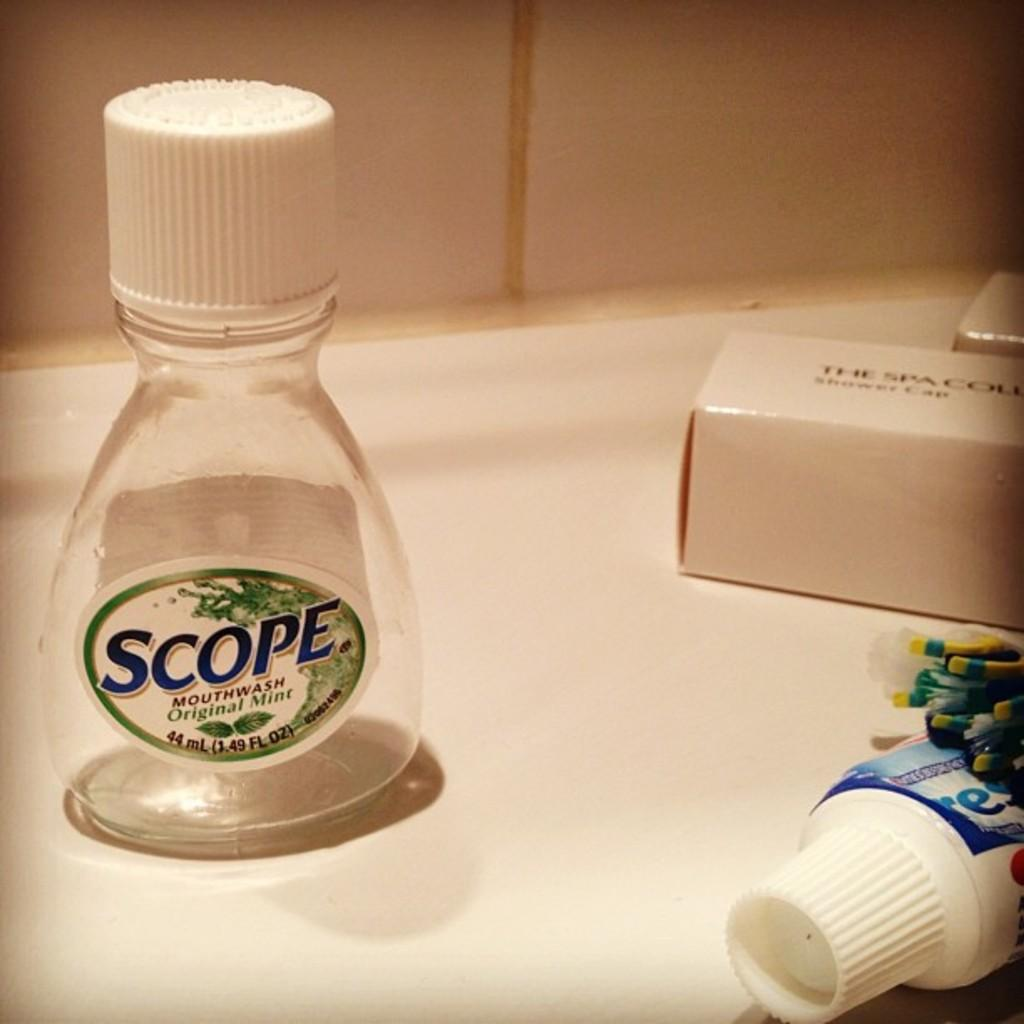<image>
Give a short and clear explanation of the subsequent image. Empty Scope bottle next to a Crest toothpaste. 